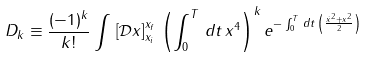<formula> <loc_0><loc_0><loc_500><loc_500>D _ { k } \equiv \frac { ( - 1 ) ^ { k } } { k ! } \int \, \left [ \mathcal { D } x \right ] _ { x _ { i } } ^ { x _ { f } } \, \left ( \int _ { 0 } ^ { T } \, d t \, x ^ { 4 } \right ) ^ { k } e ^ { - \int _ { 0 } ^ { T } \, d t \, \left ( \frac { \dot { x } ^ { 2 } + x ^ { 2 } } { 2 } \right ) }</formula> 